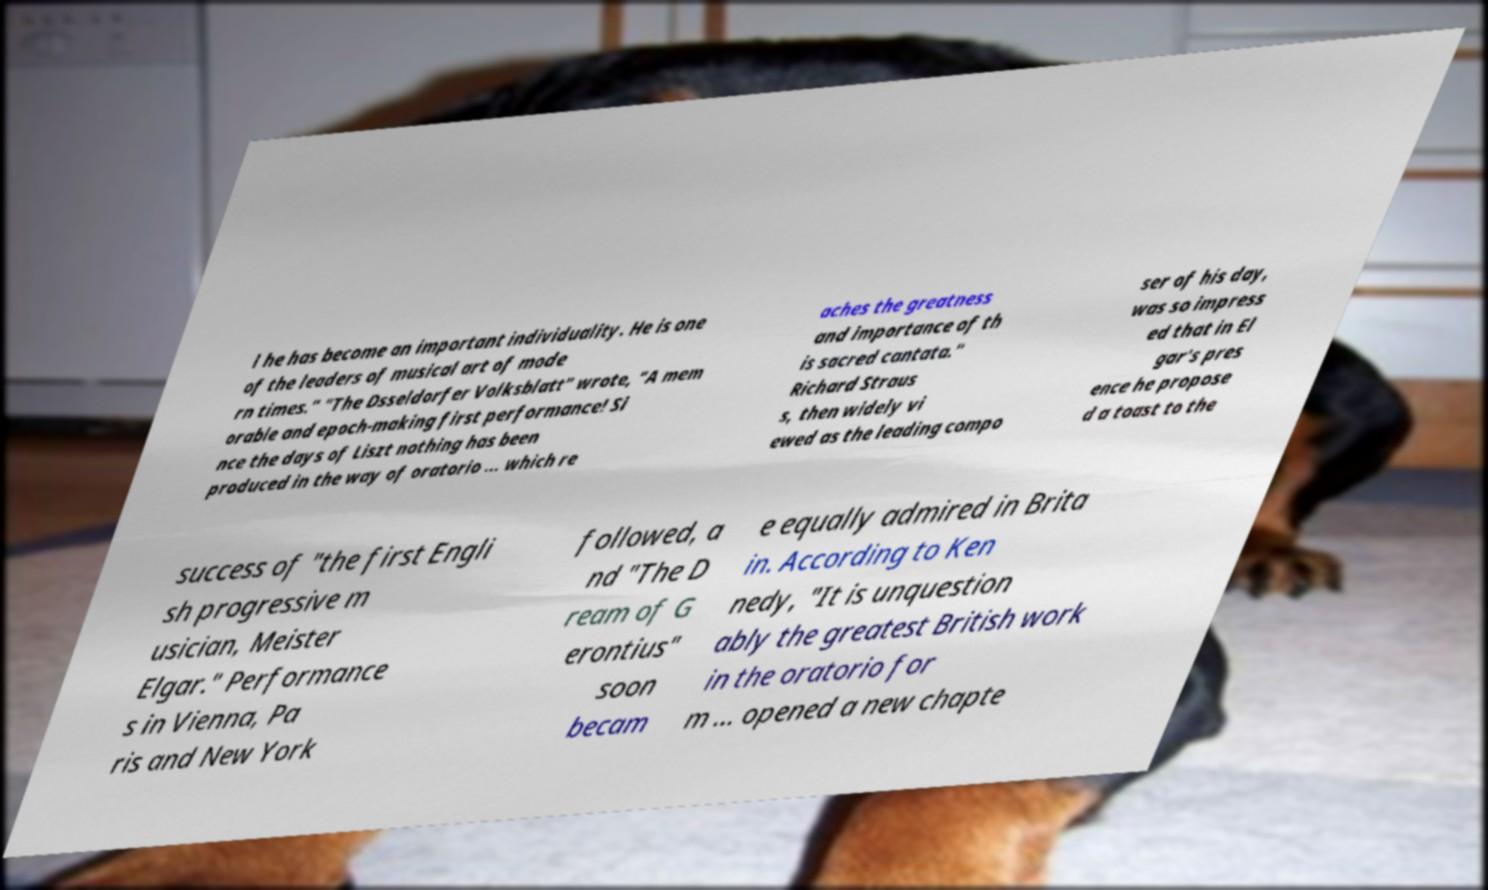Can you accurately transcribe the text from the provided image for me? l he has become an important individuality. He is one of the leaders of musical art of mode rn times." "The Dsseldorfer Volksblatt" wrote, "A mem orable and epoch-making first performance! Si nce the days of Liszt nothing has been produced in the way of oratorio ... which re aches the greatness and importance of th is sacred cantata." Richard Straus s, then widely vi ewed as the leading compo ser of his day, was so impress ed that in El gar's pres ence he propose d a toast to the success of "the first Engli sh progressive m usician, Meister Elgar." Performance s in Vienna, Pa ris and New York followed, a nd "The D ream of G erontius" soon becam e equally admired in Brita in. According to Ken nedy, "It is unquestion ably the greatest British work in the oratorio for m ... opened a new chapte 